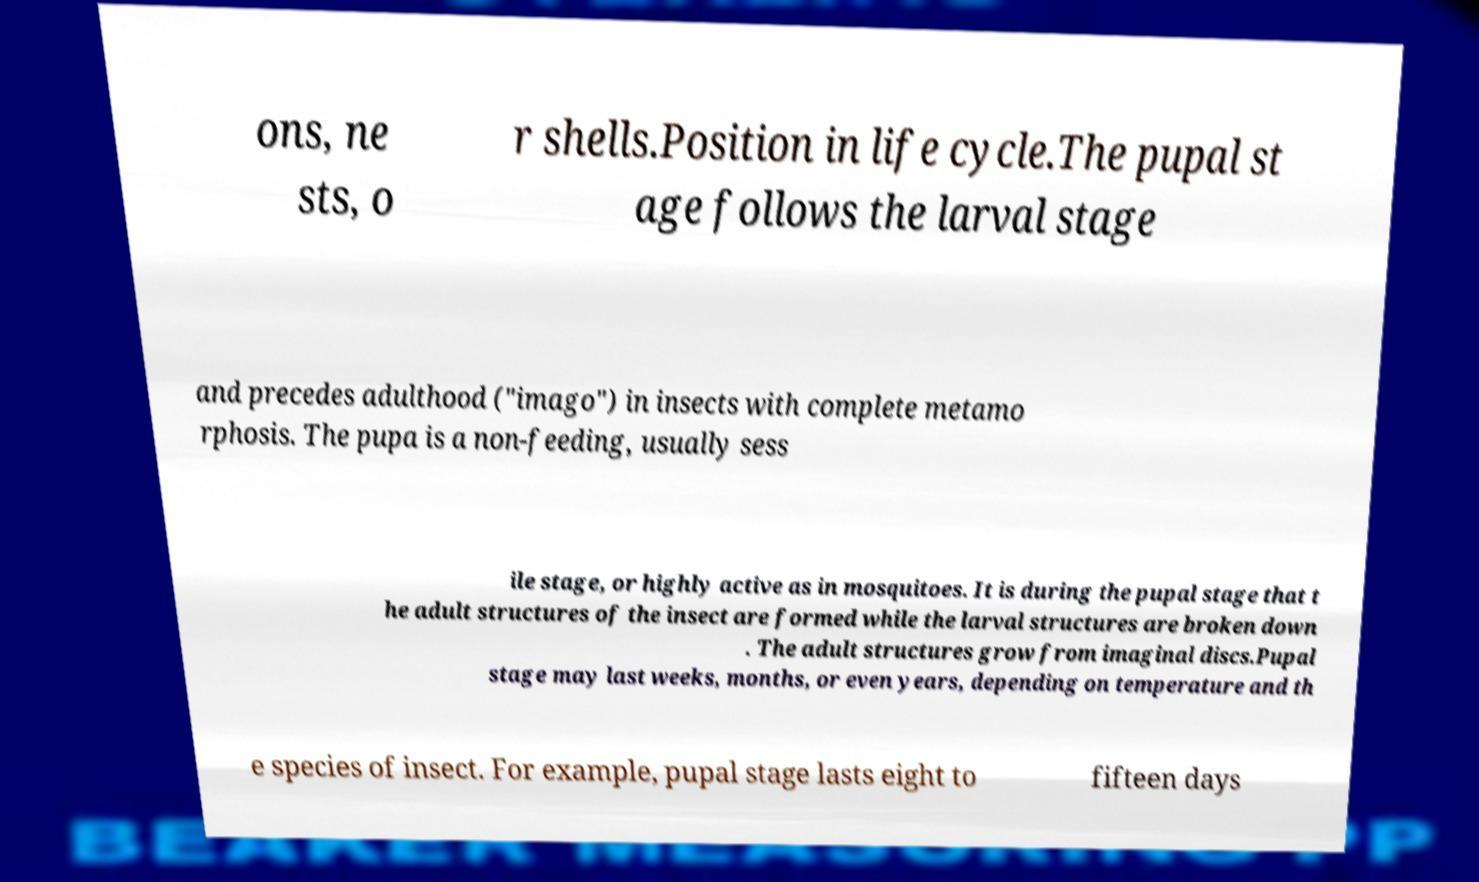There's text embedded in this image that I need extracted. Can you transcribe it verbatim? ons, ne sts, o r shells.Position in life cycle.The pupal st age follows the larval stage and precedes adulthood ("imago") in insects with complete metamo rphosis. The pupa is a non-feeding, usually sess ile stage, or highly active as in mosquitoes. It is during the pupal stage that t he adult structures of the insect are formed while the larval structures are broken down . The adult structures grow from imaginal discs.Pupal stage may last weeks, months, or even years, depending on temperature and th e species of insect. For example, pupal stage lasts eight to fifteen days 